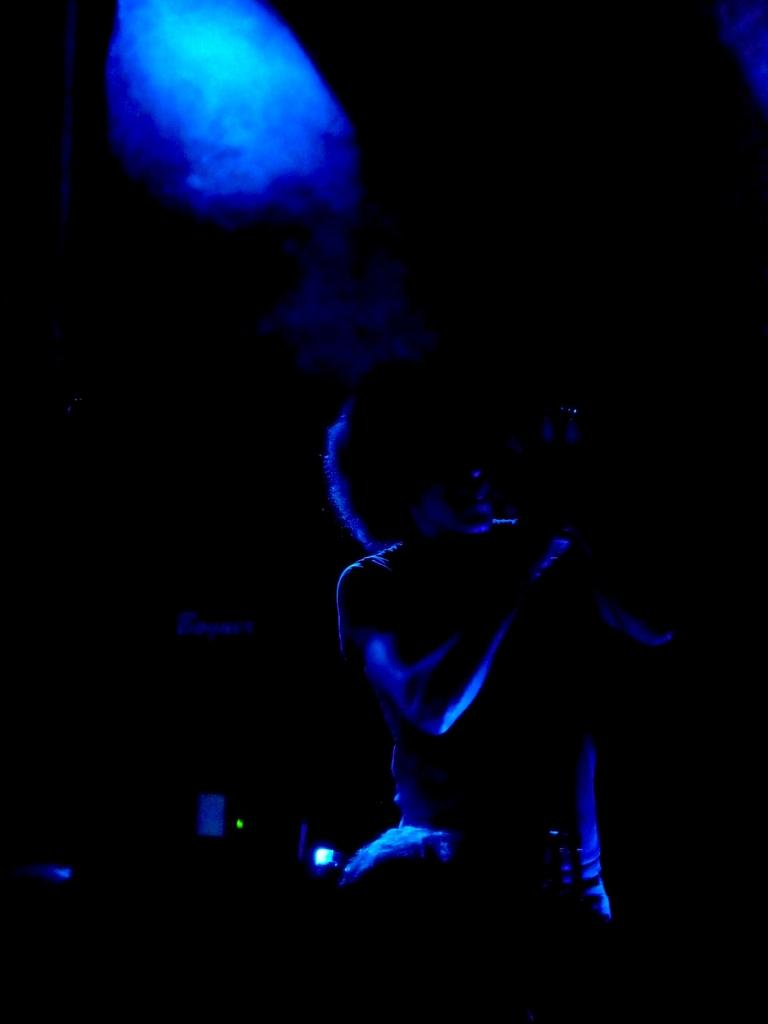What is the main subject of the image? There is a person in the middle of the image. What color light can be seen at the top of the image? There is blue color light at the top of the image. How many pages of knowledge can be seen in the hands of the person in the image? There is no indication of any pages or knowledge in the hands of the person in the image. 